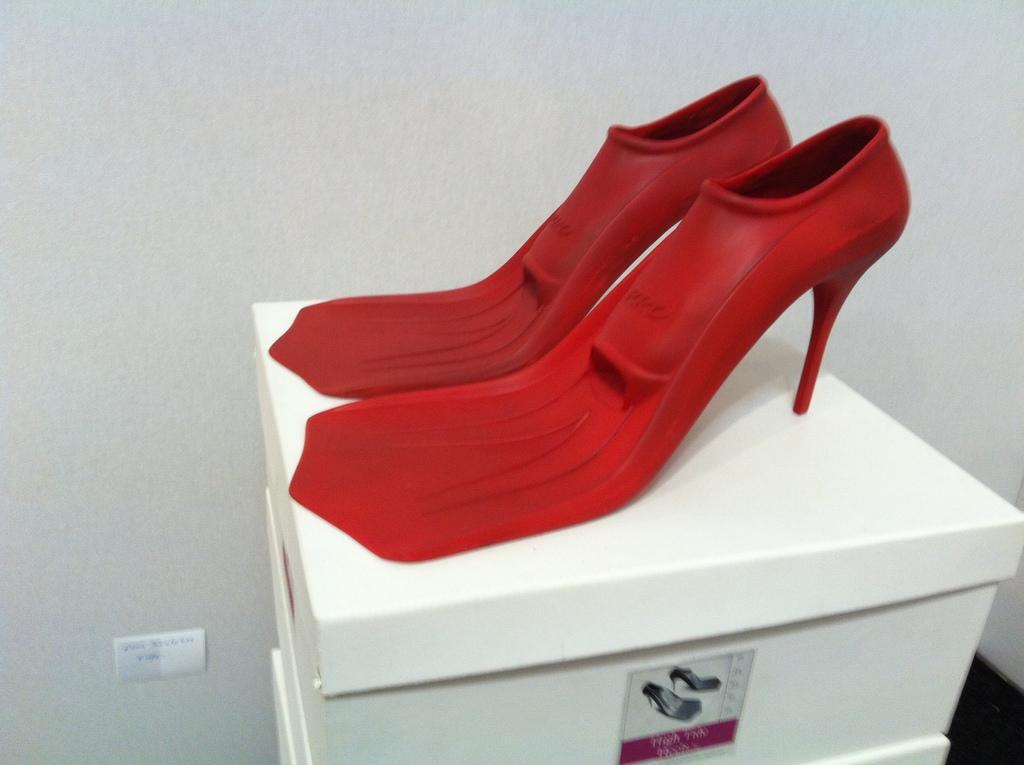How would you summarize this image in a sentence or two? In this image there are sandals which are red in colour and there are boxes which are white in colour. 